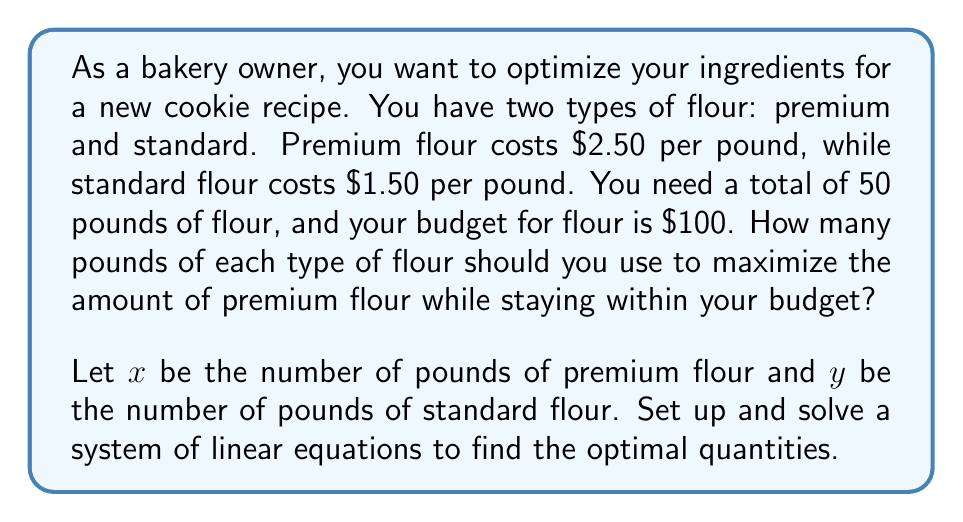Solve this math problem. Let's approach this step-by-step:

1) First, we need to set up our equations based on the given information:

   Equation 1 (total flour): $x + y = 50$
   Equation 2 (budget constraint): $2.50x + 1.50y = 100$

2) We want to solve this system of equations. Let's start by solving Equation 1 for y:

   $y = 50 - x$

3) Now, substitute this expression for y into Equation 2:

   $2.50x + 1.50(50 - x) = 100$

4) Let's simplify this equation:

   $2.50x + 75 - 1.50x = 100$
   $x + 75 = 100$

5) Solve for x:

   $x = 25$

6) Now that we know x, we can find y by substituting back into Equation 1:

   $y = 50 - 25 = 25$

7) Let's verify that this solution satisfies our budget constraint:

   $2.50(25) + 1.50(25) = 62.50 + 37.50 = 100$

Therefore, to maximize the amount of premium flour while staying within the budget, you should use 25 pounds of premium flour and 25 pounds of standard flour.
Answer: Use 25 pounds of premium flour ($x = 25$) and 25 pounds of standard flour ($y = 25$). 